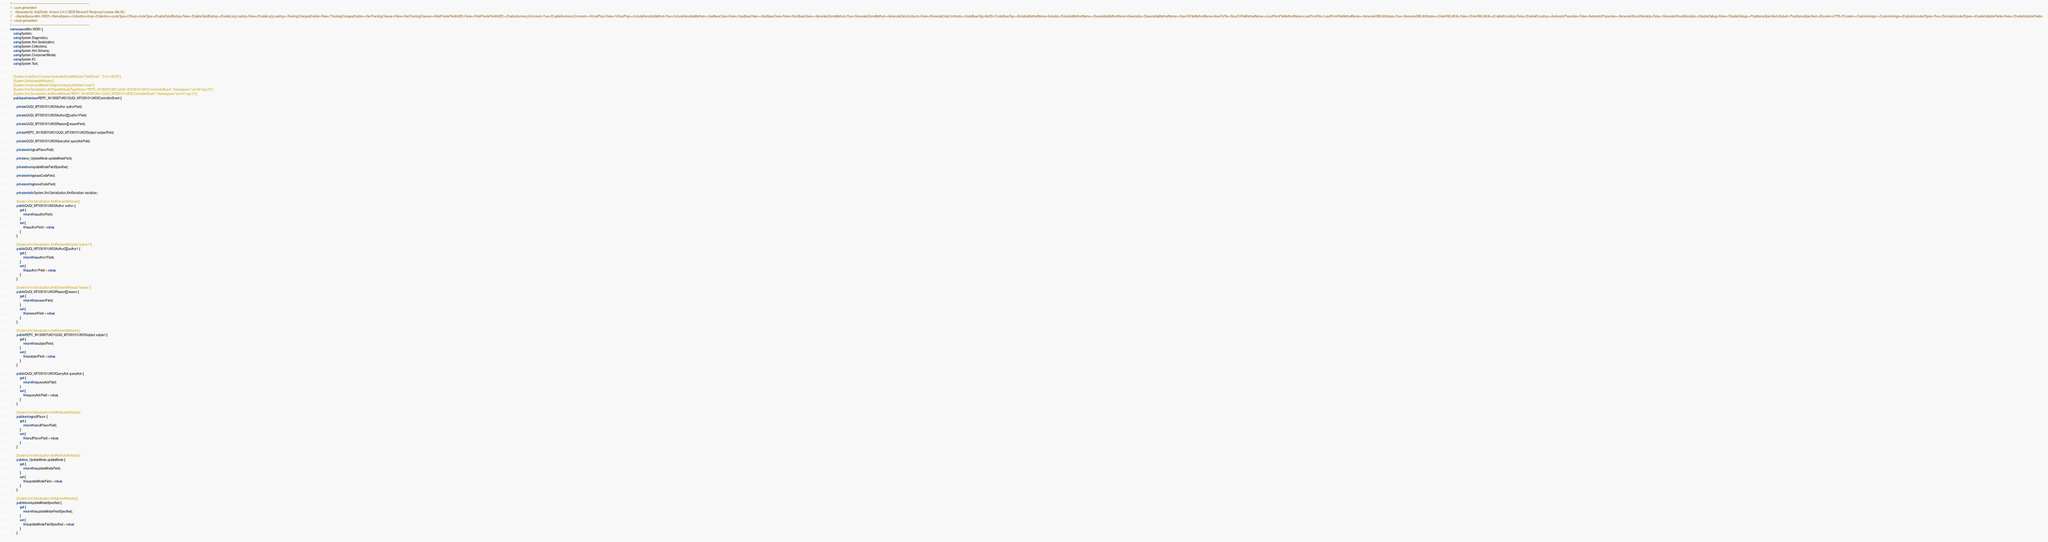Convert code to text. <code><loc_0><loc_0><loc_500><loc_500><_C#_>// ------------------------------------------------------------------------------
//  <auto-generated>
//    Generated by Xsd2Code. Version 3.4.0.18239 Microsoft Reciprocal License (Ms-RL) 
//    <NameSpace>Mim.V6301</NameSpace><Collection>Array</Collection><codeType>CSharp</codeType><EnableDataBinding>False</EnableDataBinding><EnableLazyLoading>False</EnableLazyLoading><TrackingChangesEnable>False</TrackingChangesEnable><GenTrackingClasses>False</GenTrackingClasses><HidePrivateFieldInIDE>False</HidePrivateFieldInIDE><EnableSummaryComment>True</EnableSummaryComment><VirtualProp>False</VirtualProp><IncludeSerializeMethod>True</IncludeSerializeMethod><UseBaseClass>False</UseBaseClass><GenBaseClass>False</GenBaseClass><GenerateCloneMethod>True</GenerateCloneMethod><GenerateDataContracts>False</GenerateDataContracts><CodeBaseTag>Net35</CodeBaseTag><SerializeMethodName>Serialize</SerializeMethodName><DeserializeMethodName>Deserialize</DeserializeMethodName><SaveToFileMethodName>SaveToFile</SaveToFileMethodName><LoadFromFileMethodName>LoadFromFile</LoadFromFileMethodName><GenerateXMLAttributes>True</GenerateXMLAttributes><OrderXMLAttrib>False</OrderXMLAttrib><EnableEncoding>False</EnableEncoding><AutomaticProperties>False</AutomaticProperties><GenerateShouldSerialize>False</GenerateShouldSerialize><DisableDebug>False</DisableDebug><PropNameSpecified>Default</PropNameSpecified><Encoder>UTF8</Encoder><CustomUsings></CustomUsings><ExcludeIncludedTypes>True</ExcludeIncludedTypes><EnableInitializeFields>False</EnableInitializeFields>
//  </auto-generated>
// ------------------------------------------------------------------------------
namespace Mim.V6301 {
    using System;
    using System.Diagnostics;
    using System.Xml.Serialization;
    using System.Collections;
    using System.Xml.Schema;
    using System.ComponentModel;
    using System.IO;
    using System.Text;
    
    
    [System.CodeDom.Compiler.GeneratedCodeAttribute("Xsd2Code", "3.4.0.18239")]
    [System.SerializableAttribute()]
    [System.ComponentModel.DesignerCategoryAttribute("code")]
    [System.Xml.Serialization.XmlTypeAttribute(TypeName="REPC_IN130007UK01.QUQI_MT030101UK03.ControlActEvent", Namespace="urn:hl7-org:v3")]
    [System.Xml.Serialization.XmlRootAttribute("REPC_IN130007UK01.QUQI_MT030101UK03.ControlActEvent", Namespace="urn:hl7-org:v3")]
    public partial class REPC_IN130007UK01QUQI_MT030101UK03ControlActEvent {
        
        private QUQI_MT030101UK03Author authorField;
        
        private QUQI_MT030101UK03Author2[] author1Field;
        
        private QUQI_MT030101UK03Reason[] reasonField;
        
        private REPC_IN130007UK01QUQI_MT030101UK03Subject subjectField;
        
        private QUQI_MT030101UK03QueryAck queryAckField;
        
        private string nullFlavorField;
        
        private cs_UpdateMode updateModeField;
        
        private bool updateModeFieldSpecified;
        
        private string classCodeField;
        
        private string moodCodeField;
        
        private static System.Xml.Serialization.XmlSerializer serializer;
        
        [System.Xml.Serialization.XmlElementAttribute()]
        public QUQI_MT030101UK03Author author {
            get {
                return this.authorField;
            }
            set {
                this.authorField = value;
            }
        }
        
        [System.Xml.Serialization.XmlElementAttribute("author1")]
        public QUQI_MT030101UK03Author2[] author1 {
            get {
                return this.author1Field;
            }
            set {
                this.author1Field = value;
            }
        }
        
        [System.Xml.Serialization.XmlElementAttribute("reason")]
        public QUQI_MT030101UK03Reason[] reason {
            get {
                return this.reasonField;
            }
            set {
                this.reasonField = value;
            }
        }
        
        [System.Xml.Serialization.XmlElementAttribute()]
        public REPC_IN130007UK01QUQI_MT030101UK03Subject subject {
            get {
                return this.subjectField;
            }
            set {
                this.subjectField = value;
            }
        }
        
        public QUQI_MT030101UK03QueryAck queryAck {
            get {
                return this.queryAckField;
            }
            set {
                this.queryAckField = value;
            }
        }
        
        [System.Xml.Serialization.XmlAttributeAttribute()]
        public string nullFlavor {
            get {
                return this.nullFlavorField;
            }
            set {
                this.nullFlavorField = value;
            }
        }
        
        [System.Xml.Serialization.XmlAttributeAttribute()]
        public cs_UpdateMode updateMode {
            get {
                return this.updateModeField;
            }
            set {
                this.updateModeField = value;
            }
        }
        
        [System.Xml.Serialization.XmlIgnoreAttribute()]
        public bool updateModeSpecified {
            get {
                return this.updateModeFieldSpecified;
            }
            set {
                this.updateModeFieldSpecified = value;
            }
        }
        </code> 